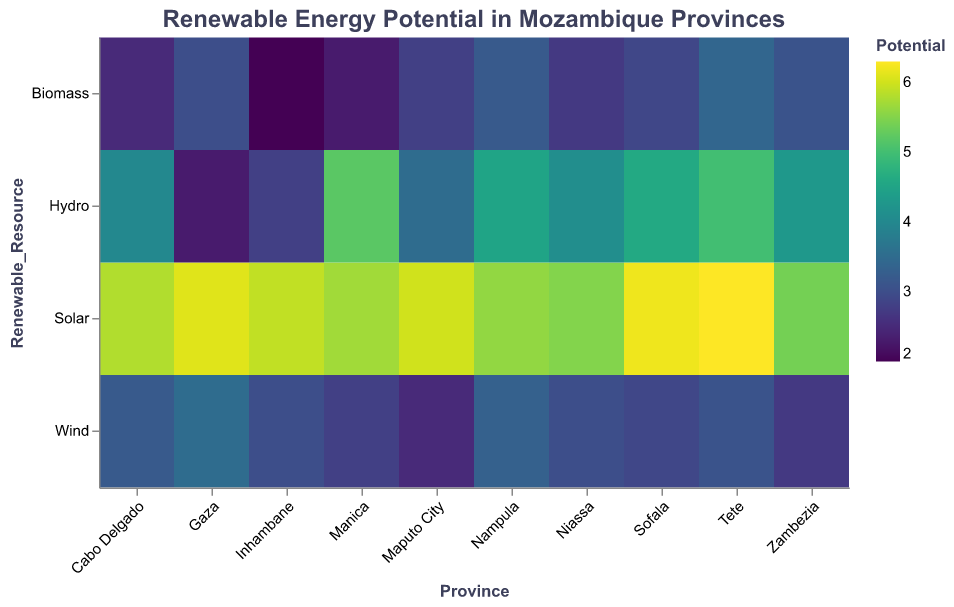What is the solar energy potential in Tete? To find the solar energy potential in Tete, locate the value in the heatmap where the x-axis is 'Tete' and the y-axis is 'Solar'.
Answer: 6.3 Which province has the highest biomass potential? Scan the heatmap for the highest value under the 'Biomass' category on the y-axis and locate the corresponding province on the x-axis.
Answer: Tete What is the average potential for hydro energy across all provinces? Add up all the hydro energy values for each province and divide by the number of provinces. The values are (4.0 + 2.3 + 2.8 + 3.5 + 5.2 + 4.5 + 4.1 + 4.6 + 5.0 + 4.3) = 40.3. There are 10 provinces, so 40.3/10 = 4.03.
Answer: 4.03 Which renewable resource offers the highest overall potential in Mozambique? Compare the highest potentials for each renewable resource across all provinces by scanning the heatmap. Determine the highest value overall. Solar: 6.3, Wind: 3.5, Hydro: 5.2, Biomass: 3.4.
Answer: Solar Are there any provinces where wind energy potential exceeds 3.0? Look at the wind energy potentials for all provinces and see if any value exceeds 3.0.
Answer: Yes, Cabo Delgado, Gaza, Nampula, and Tete Which province has the lowest hydro potential? Scan the heatmap for the lowest value under the 'Hydro' category on the y-axis and locate the corresponding province on the x-axis.
Answer: Gaza How does the biomass potential in Niassa compare to Maputo City? Locate the biomass potentials for Niassa and Maputo City, and compare their values. Niassa: 2.7, Maputo City: 2.8.
Answer: Lower What is the combined potential for renewable energy in Nampula? Add the values of all renewable resources in Nampula. (5.6 + 3.3 + 4.5 + 3.2) = 16.6.
Answer: 16.6 Which province has the highest variability in renewable energy potentials among the four resources? Calculate the range of each province's potential values by subtracting the lowest value from the highest value for solar, wind, hydro, and biomass potentials for each province. The province with the highest range has the greatest variability.
Answer: Manica (range: 5.2 - 2.3 = 2.9) Does anyone provide a significant hydro potential higher than 5.0? Scan the hydro potential values across all provinces for any values exceeding 5.0.
Answer: Yes, Manica and Tete 